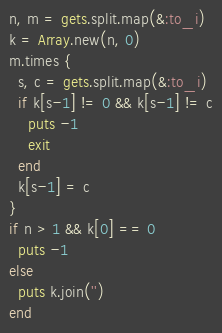<code> <loc_0><loc_0><loc_500><loc_500><_Ruby_>n, m = gets.split.map(&:to_i)
k = Array.new(n, 0)
m.times {
  s, c = gets.split.map(&:to_i)
  if k[s-1] != 0 && k[s-1] != c
    puts -1
    exit
  end
  k[s-1] = c
}
if n > 1 && k[0] == 0
  puts -1
else
  puts k.join('')
end
</code> 